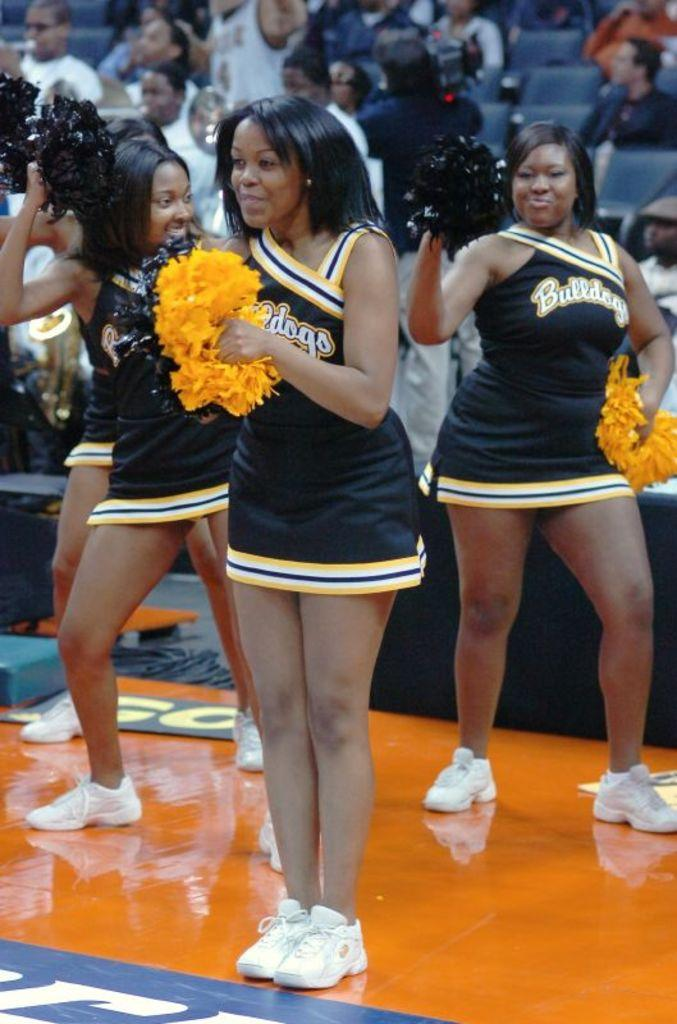Provide a one-sentence caption for the provided image. Four women wearing a Bulldogs jersey cheerleading for an audience. 